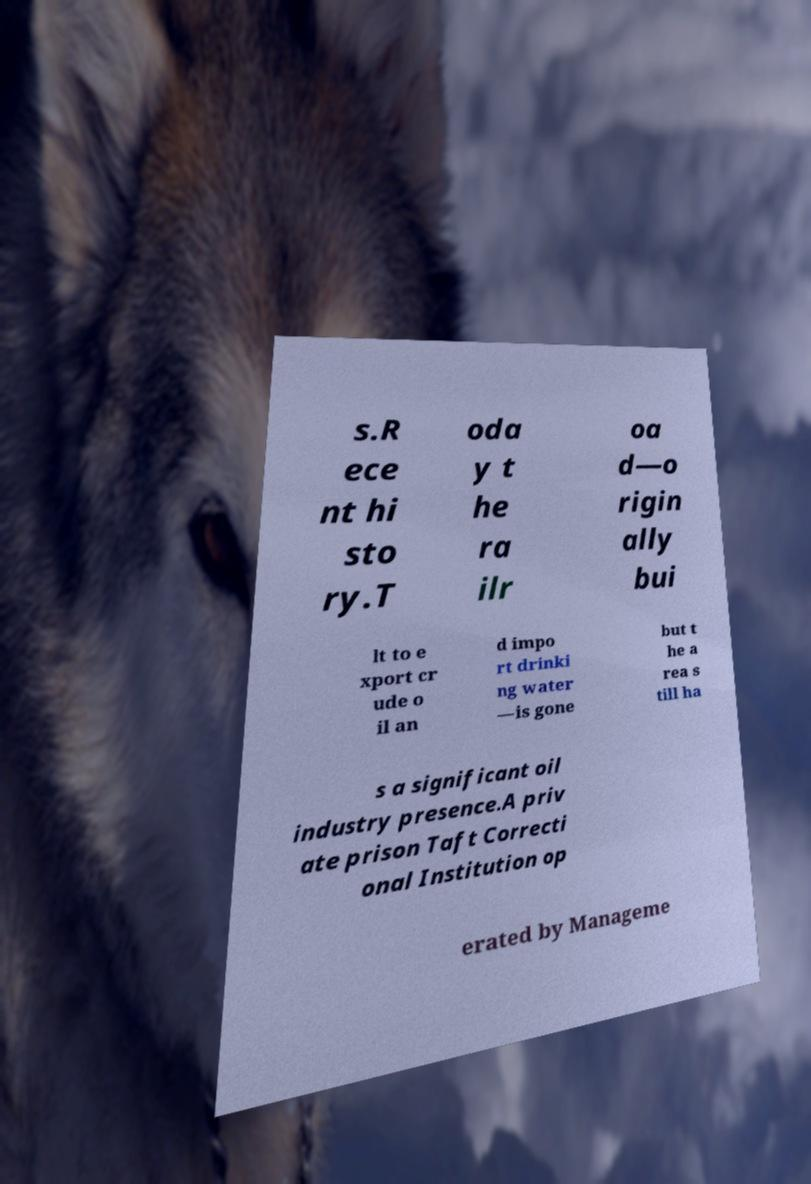Could you extract and type out the text from this image? s.R ece nt hi sto ry.T oda y t he ra ilr oa d—o rigin ally bui lt to e xport cr ude o il an d impo rt drinki ng water —is gone but t he a rea s till ha s a significant oil industry presence.A priv ate prison Taft Correcti onal Institution op erated by Manageme 